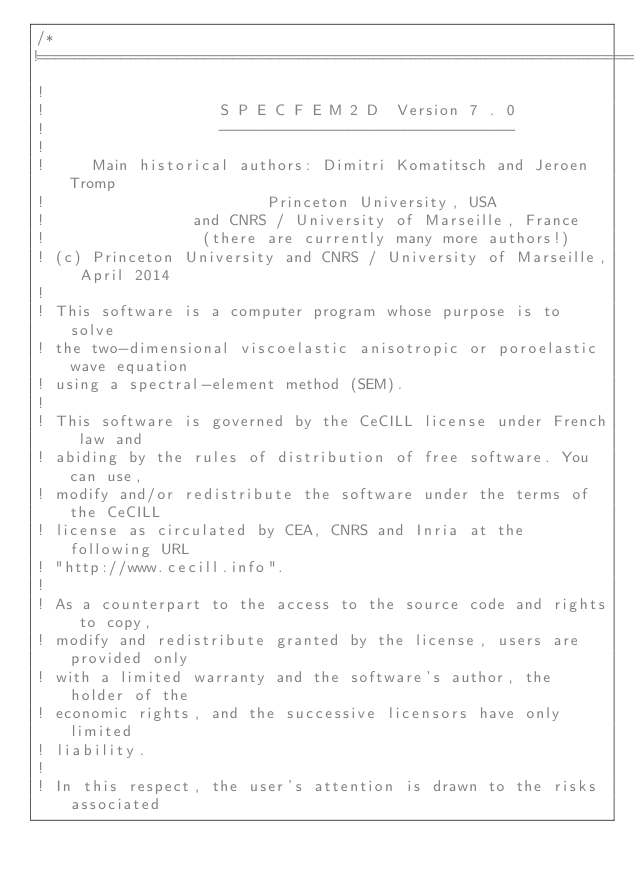Convert code to text. <code><loc_0><loc_0><loc_500><loc_500><_Cuda_>/*
!========================================================================
!
!                   S P E C F E M 2 D  Version 7 . 0
!                   --------------------------------
!
!     Main historical authors: Dimitri Komatitsch and Jeroen Tromp
!                        Princeton University, USA
!                and CNRS / University of Marseille, France
!                 (there are currently many more authors!)
! (c) Princeton University and CNRS / University of Marseille, April 2014
!
! This software is a computer program whose purpose is to solve
! the two-dimensional viscoelastic anisotropic or poroelastic wave equation
! using a spectral-element method (SEM).
!
! This software is governed by the CeCILL license under French law and
! abiding by the rules of distribution of free software. You can use,
! modify and/or redistribute the software under the terms of the CeCILL
! license as circulated by CEA, CNRS and Inria at the following URL
! "http://www.cecill.info".
!
! As a counterpart to the access to the source code and rights to copy,
! modify and redistribute granted by the license, users are provided only
! with a limited warranty and the software's author, the holder of the
! economic rights, and the successive licensors have only limited
! liability.
!
! In this respect, the user's attention is drawn to the risks associated</code> 